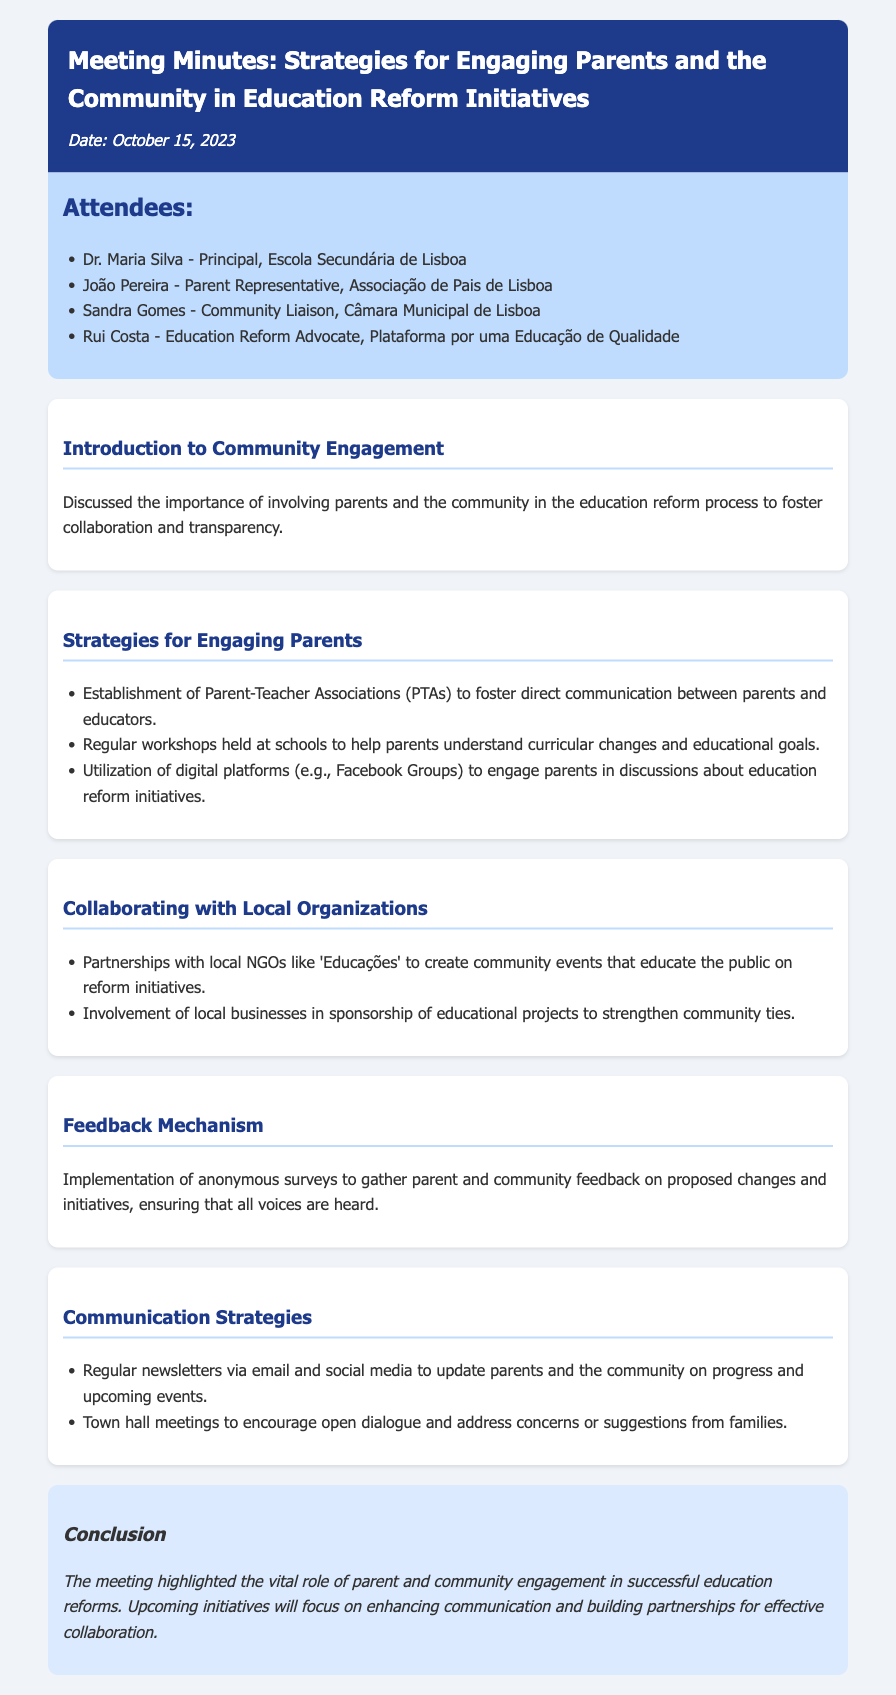What was the date of the meeting? The date of the meeting is stated at the top of the document.
Answer: October 15, 2023 Who is the Parent Representative at the meeting? The document lists the attendees, including their roles.
Answer: João Pereira What is one of the strategies for engaging parents mentioned? The document provides a list of strategies discussed in the agenda.
Answer: Establishment of Parent-Teacher Associations Which local organization was mentioned for collaboration? The document lists local organizations that were discussed for collaboration during the meeting.
Answer: Educações How will feedback from parents and the community be gathered? The document specifies a method for gathering feedback.
Answer: Anonymous surveys What role does Dr. Maria Silva hold? The document outlines the attendees and their respective roles.
Answer: Principal What type of meetings will be held to encourage open dialogue? The document indicates the types of meetings planned to engage the community.
Answer: Town hall meetings What color was used for the meeting minutes header? The document describes the stylistic choices, including colors used in the header.
Answer: Blue 